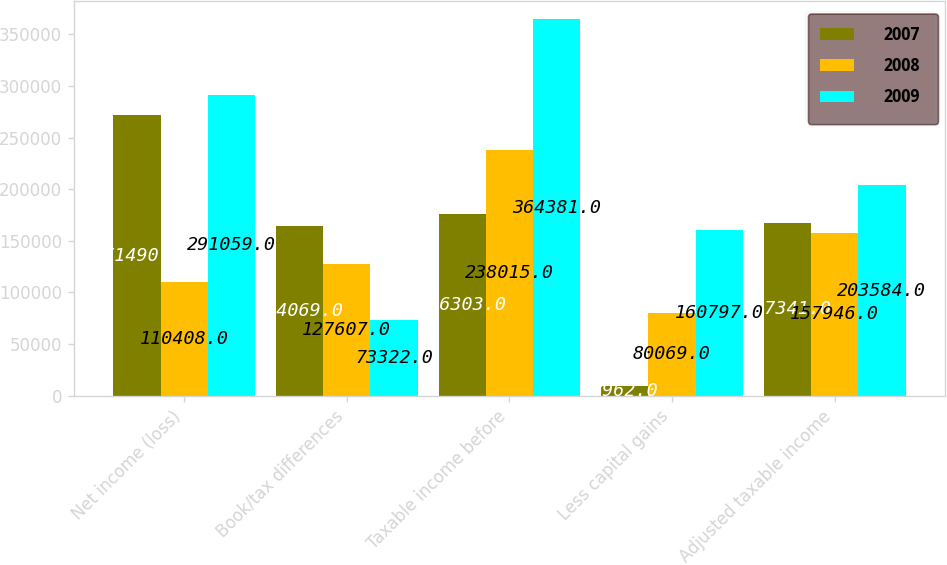Convert chart to OTSL. <chart><loc_0><loc_0><loc_500><loc_500><stacked_bar_chart><ecel><fcel>Net income (loss)<fcel>Book/tax differences<fcel>Taxable income before<fcel>Less capital gains<fcel>Adjusted taxable income<nl><fcel>2007<fcel>271490<fcel>164069<fcel>176303<fcel>8962<fcel>167341<nl><fcel>2008<fcel>110408<fcel>127607<fcel>238015<fcel>80069<fcel>157946<nl><fcel>2009<fcel>291059<fcel>73322<fcel>364381<fcel>160797<fcel>203584<nl></chart> 